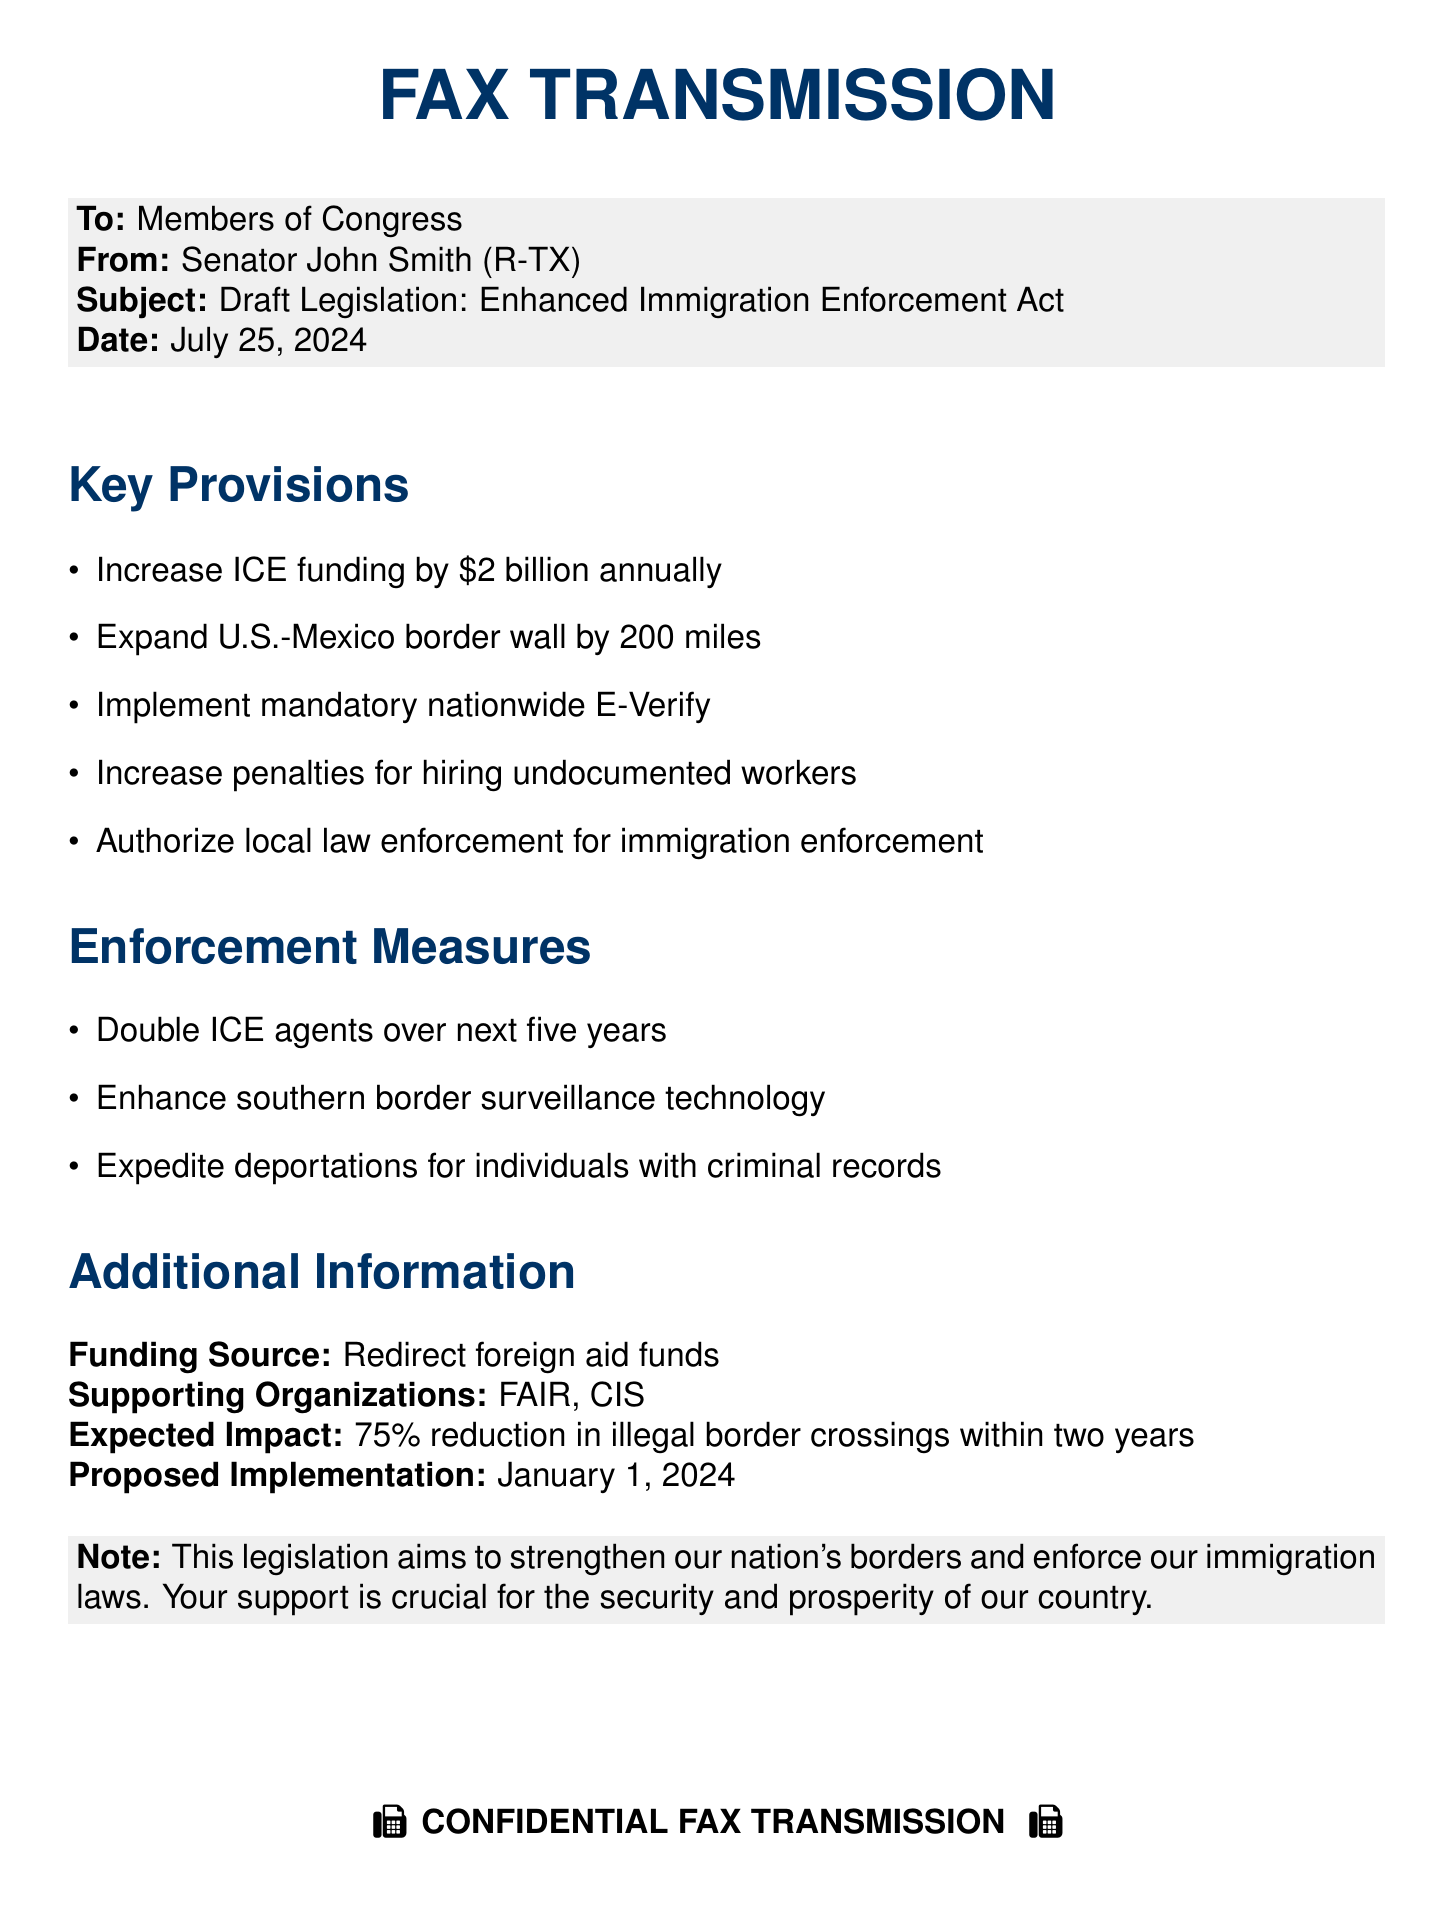What is the subject of the fax? The subject of the fax is stated at the top, highlighting the focus of the transmission.
Answer: Enhanced Immigration Enforcement Act Who is the sender of the fax? The sender is identified in the header section, specifying the person responsible for the communication.
Answer: Senator John Smith (R-TX) What is the proposed increase in ICE funding? The document specifies a financial detail regarding the funding for ICE.
Answer: $2 billion How many miles is the border wall proposed to be expanded? The document mentions a specific measure regarding the border wall in terms of distance.
Answer: 200 miles What is the expected reduction in illegal border crossings? The document anticipates an impact based on the proposed legislation's measures.
Answer: 75% reduction What is the proposed implementation date for the legislation? The date of implementation is clearly indicated in the additional information section of the fax.
Answer: January 1, 2024 What organizations support this legislation? The supporting organizations related to the legislation are listed in the document.
Answer: FAIR, CIS What type of agents is planned to be doubled? The document outlines a specific type of personnel whose numbers are intended to increase.
Answer: ICE agents What measure is suggested for local law enforcement? The text includes a specific authorization regarding the involvement of local law enforcement.
Answer: Immigration enforcement 